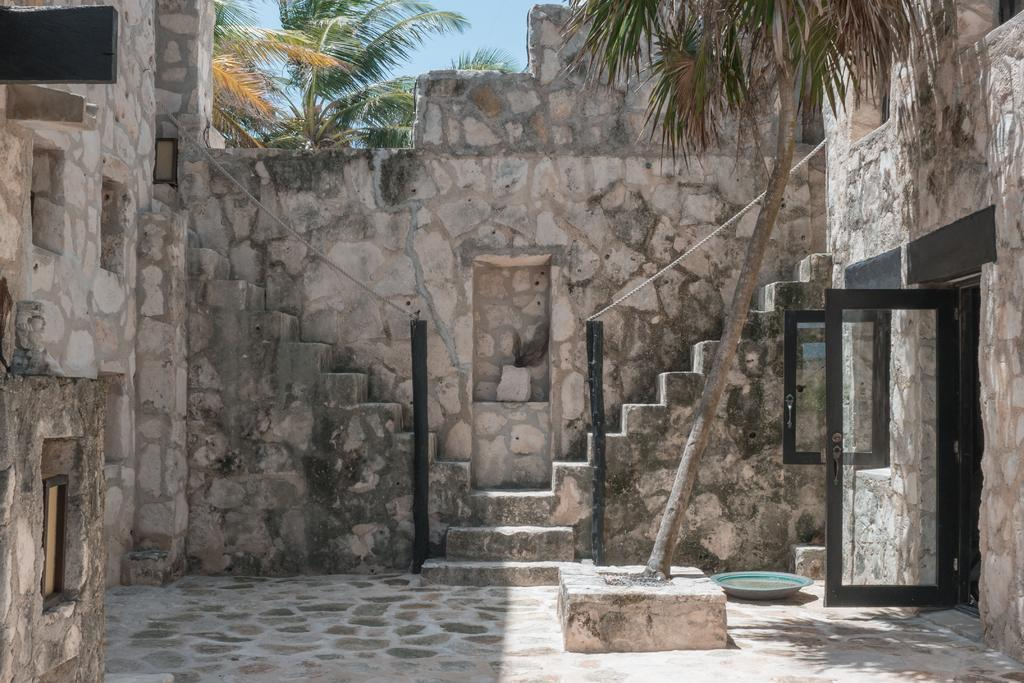What is located on the path in the image? There is a tree on a path in the image. What is on the right side of the tree? There is a glass door on the right side of the tree. How is the glass door connected to the surrounding structure? The glass door is connected to a wall. What is behind the tree in the image? There is a wall behind the tree. What can be seen beyond the wall in the image? There are trees visible behind the wall. What is visible in the background of the image? The sky is visible in the background of the image. How does the tree stretch its branches towards the dock in the image? There is no dock present in the image, and the tree does not stretch its branches in the image. 